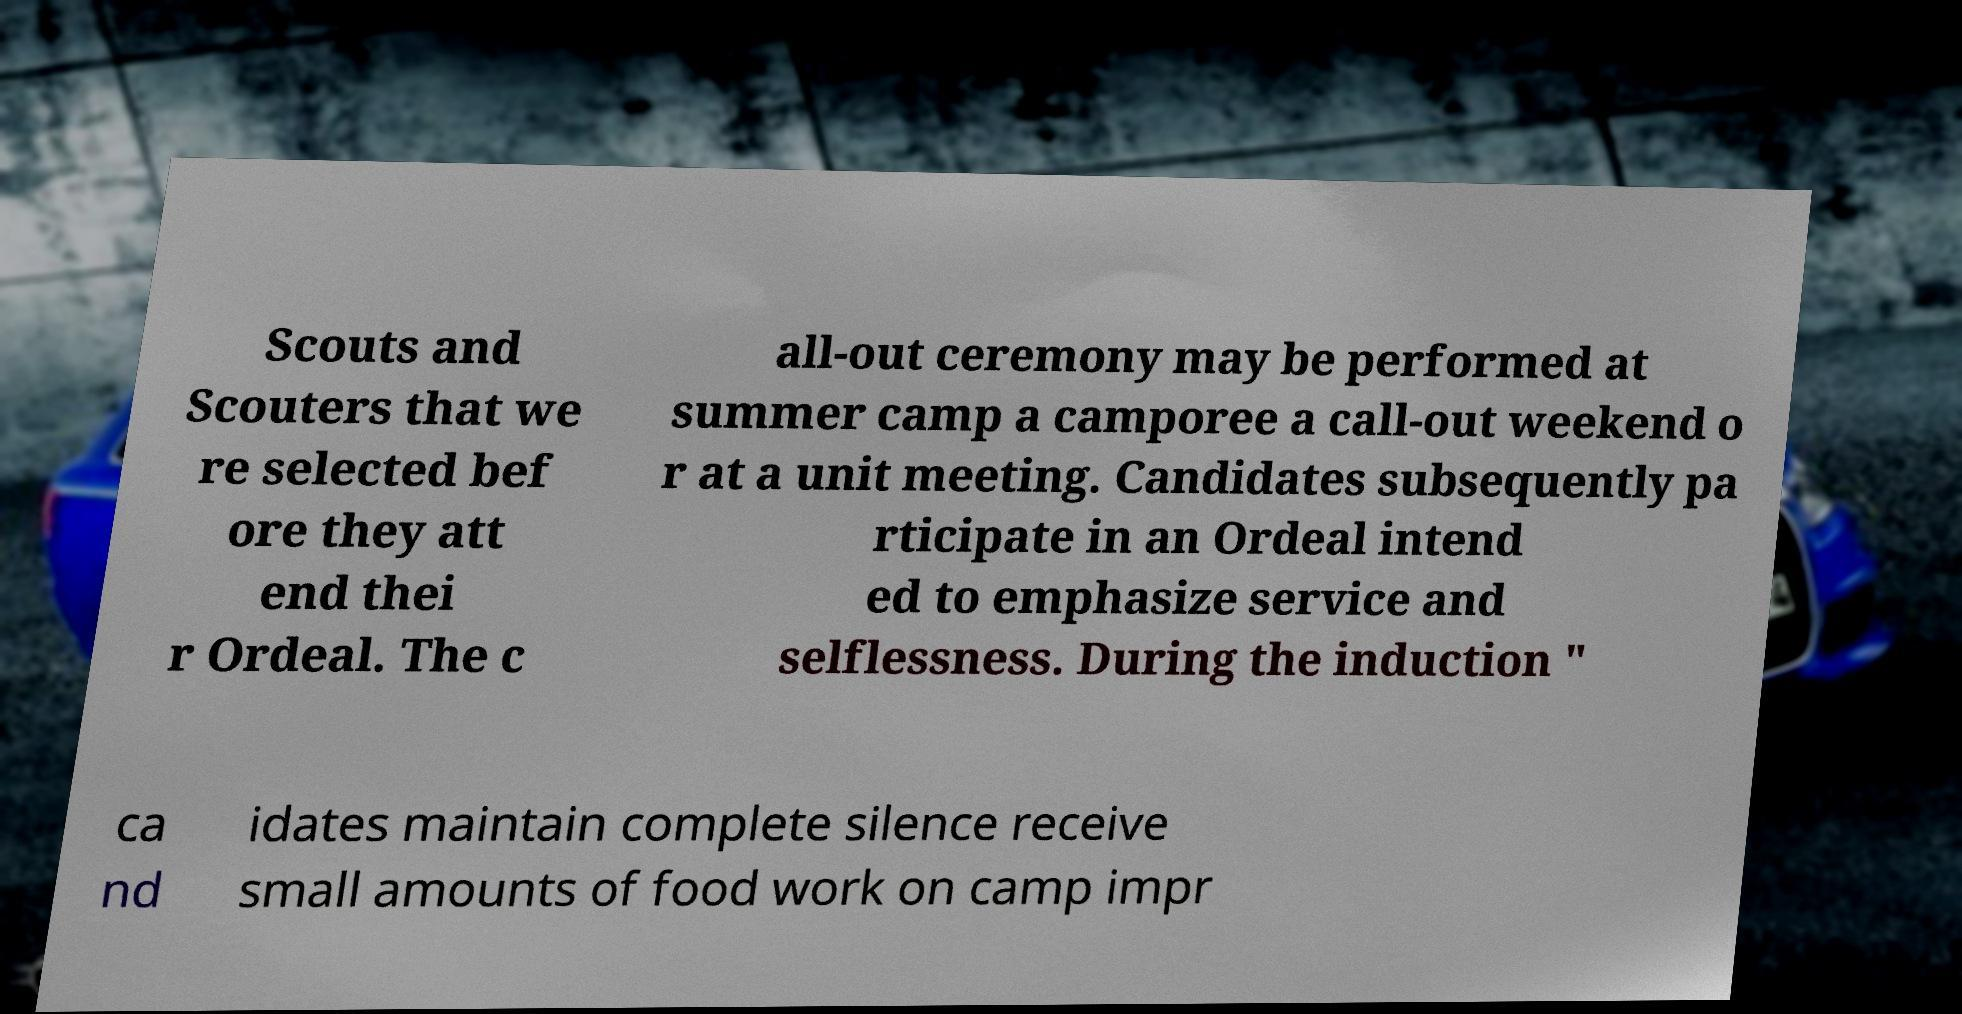Please identify and transcribe the text found in this image. Scouts and Scouters that we re selected bef ore they att end thei r Ordeal. The c all-out ceremony may be performed at summer camp a camporee a call-out weekend o r at a unit meeting. Candidates subsequently pa rticipate in an Ordeal intend ed to emphasize service and selflessness. During the induction " ca nd idates maintain complete silence receive small amounts of food work on camp impr 